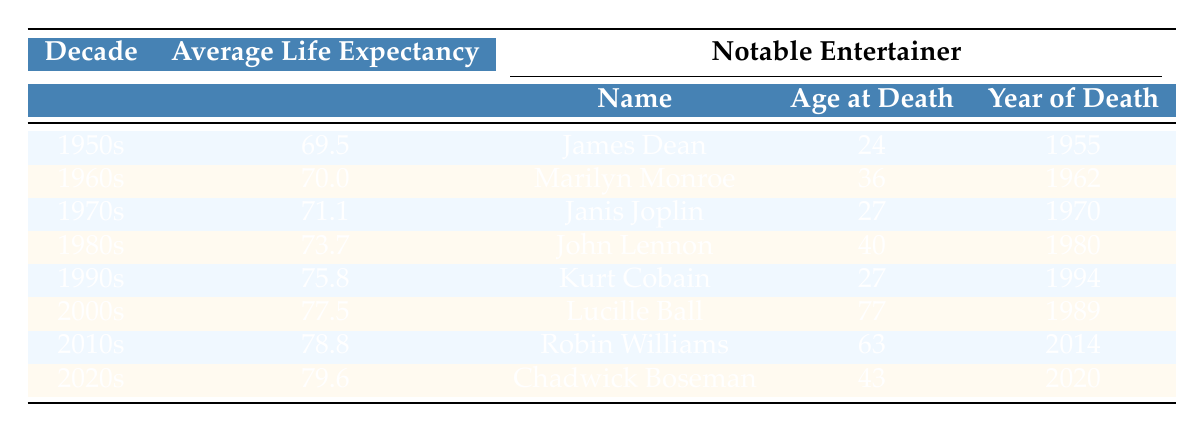What was the average life expectancy in the 1980s? The table shows that the average life expectancy for the 1980s is clearly listed as 73.7 years.
Answer: 73.7 years Which notable entertainer died in the 1990s at the age of 27? The table lists Kurt Cobain as the notable entertainer from the 1990s, and his age at death was 27.
Answer: Kurt Cobain Was the average life expectancy higher in the 2000s compared to the 1990s? The average life expectancy in the 2000s is 77.5 years and in the 1990s it is 75.8 years. Since 77.5 is greater than 75.8, the answer is yes.
Answer: Yes What is the difference in average life expectancy between the 1950s and 2020s? The average life expectancy for the 1950s is 69.5 years, and for the 2020s it is 79.6 years. The difference is 79.6 - 69.5 = 10.1 years.
Answer: 10.1 years Did any notable entertainer die in the 2000s? The table shows that Lucille Ball, who died in 1989, was noted under the 2000s section, which means no notable entertainer died in the 2000s based on this information.
Answer: No What was the age of Marilyn Monroe at the time of her death? According to the table, Marilyn Monroe was 36 years old at the time of her death in 1962.
Answer: 36 years Which decade had the oldest average life expectancy? To determine which decade had the oldest average life expectancy, we can compare the averages listed in the table: 69.5 (1950s), 70.0 (1960s), 71.1 (1970s), 73.7 (1980s), 75.8 (1990s), 77.5 (2000s), 78.8 (2010s), and 79.6 (2020s). The highest value is 79.6 for the 2020s.
Answer: 2020s What is the average life expectancy for the entertainers from the 1990s and 2010s combined? The average life expectancy for the 1990s is 75.8 years, and for the 2010s, it is 78.8 years. To find the combined average, we sum these up: 75.8 + 78.8 = 154.6 and then divide by 2, which gives 154.6/2 = 77.3 years.
Answer: 77.3 years 